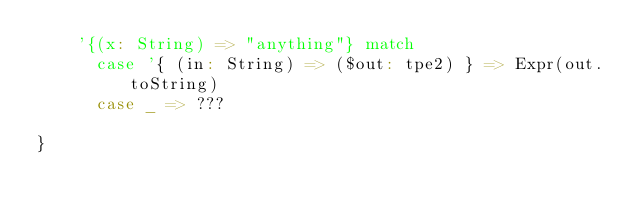Convert code to text. <code><loc_0><loc_0><loc_500><loc_500><_Scala_>    '{(x: String) => "anything"} match
      case '{ (in: String) => ($out: tpe2) } => Expr(out.toString)
      case _ => ???

}
</code> 